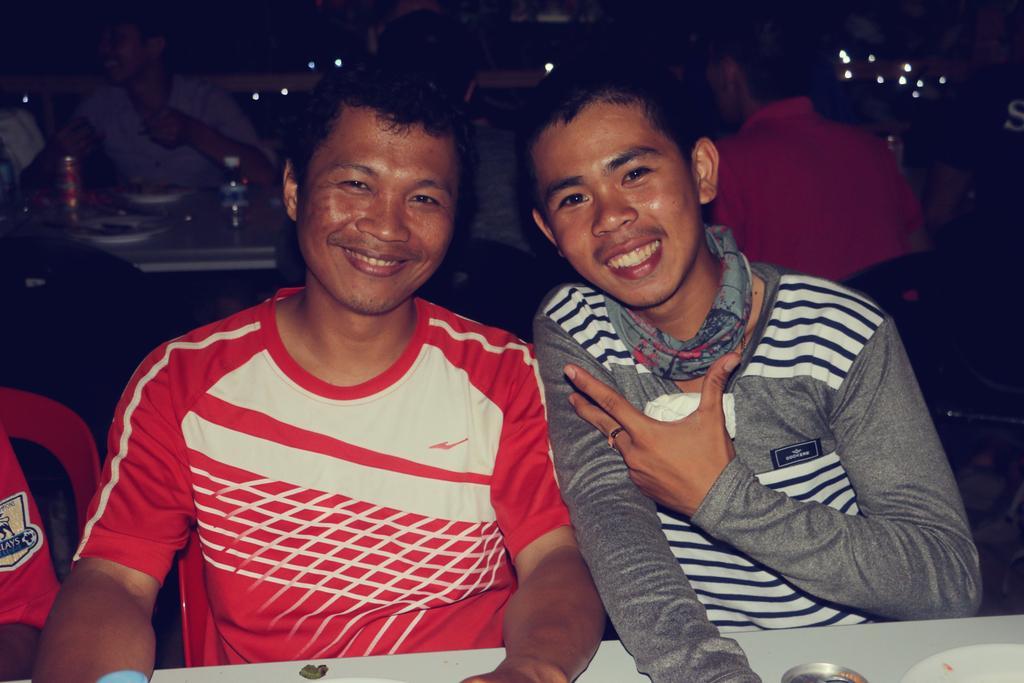Please provide a concise description of this image. In this image people are sitting on the chairs. At the center there is a table and on top of it there is a bottle, plates and one tin. 